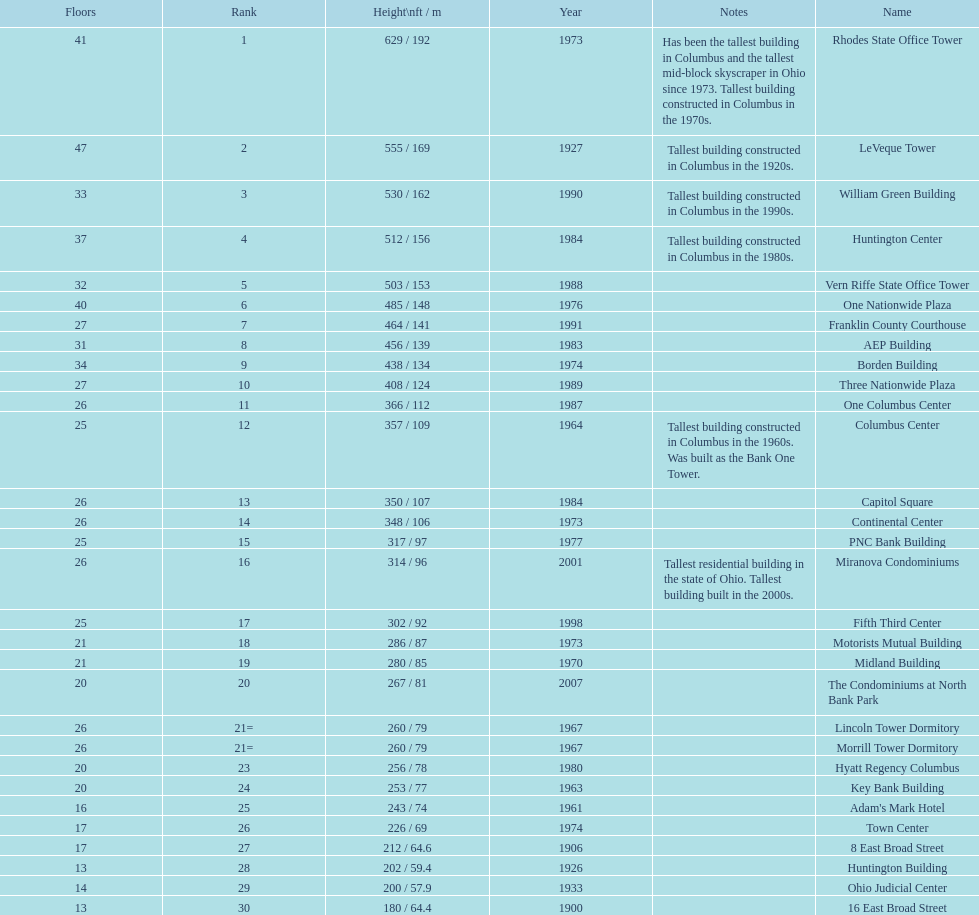What is the tallest building in columbus? Rhodes State Office Tower. 